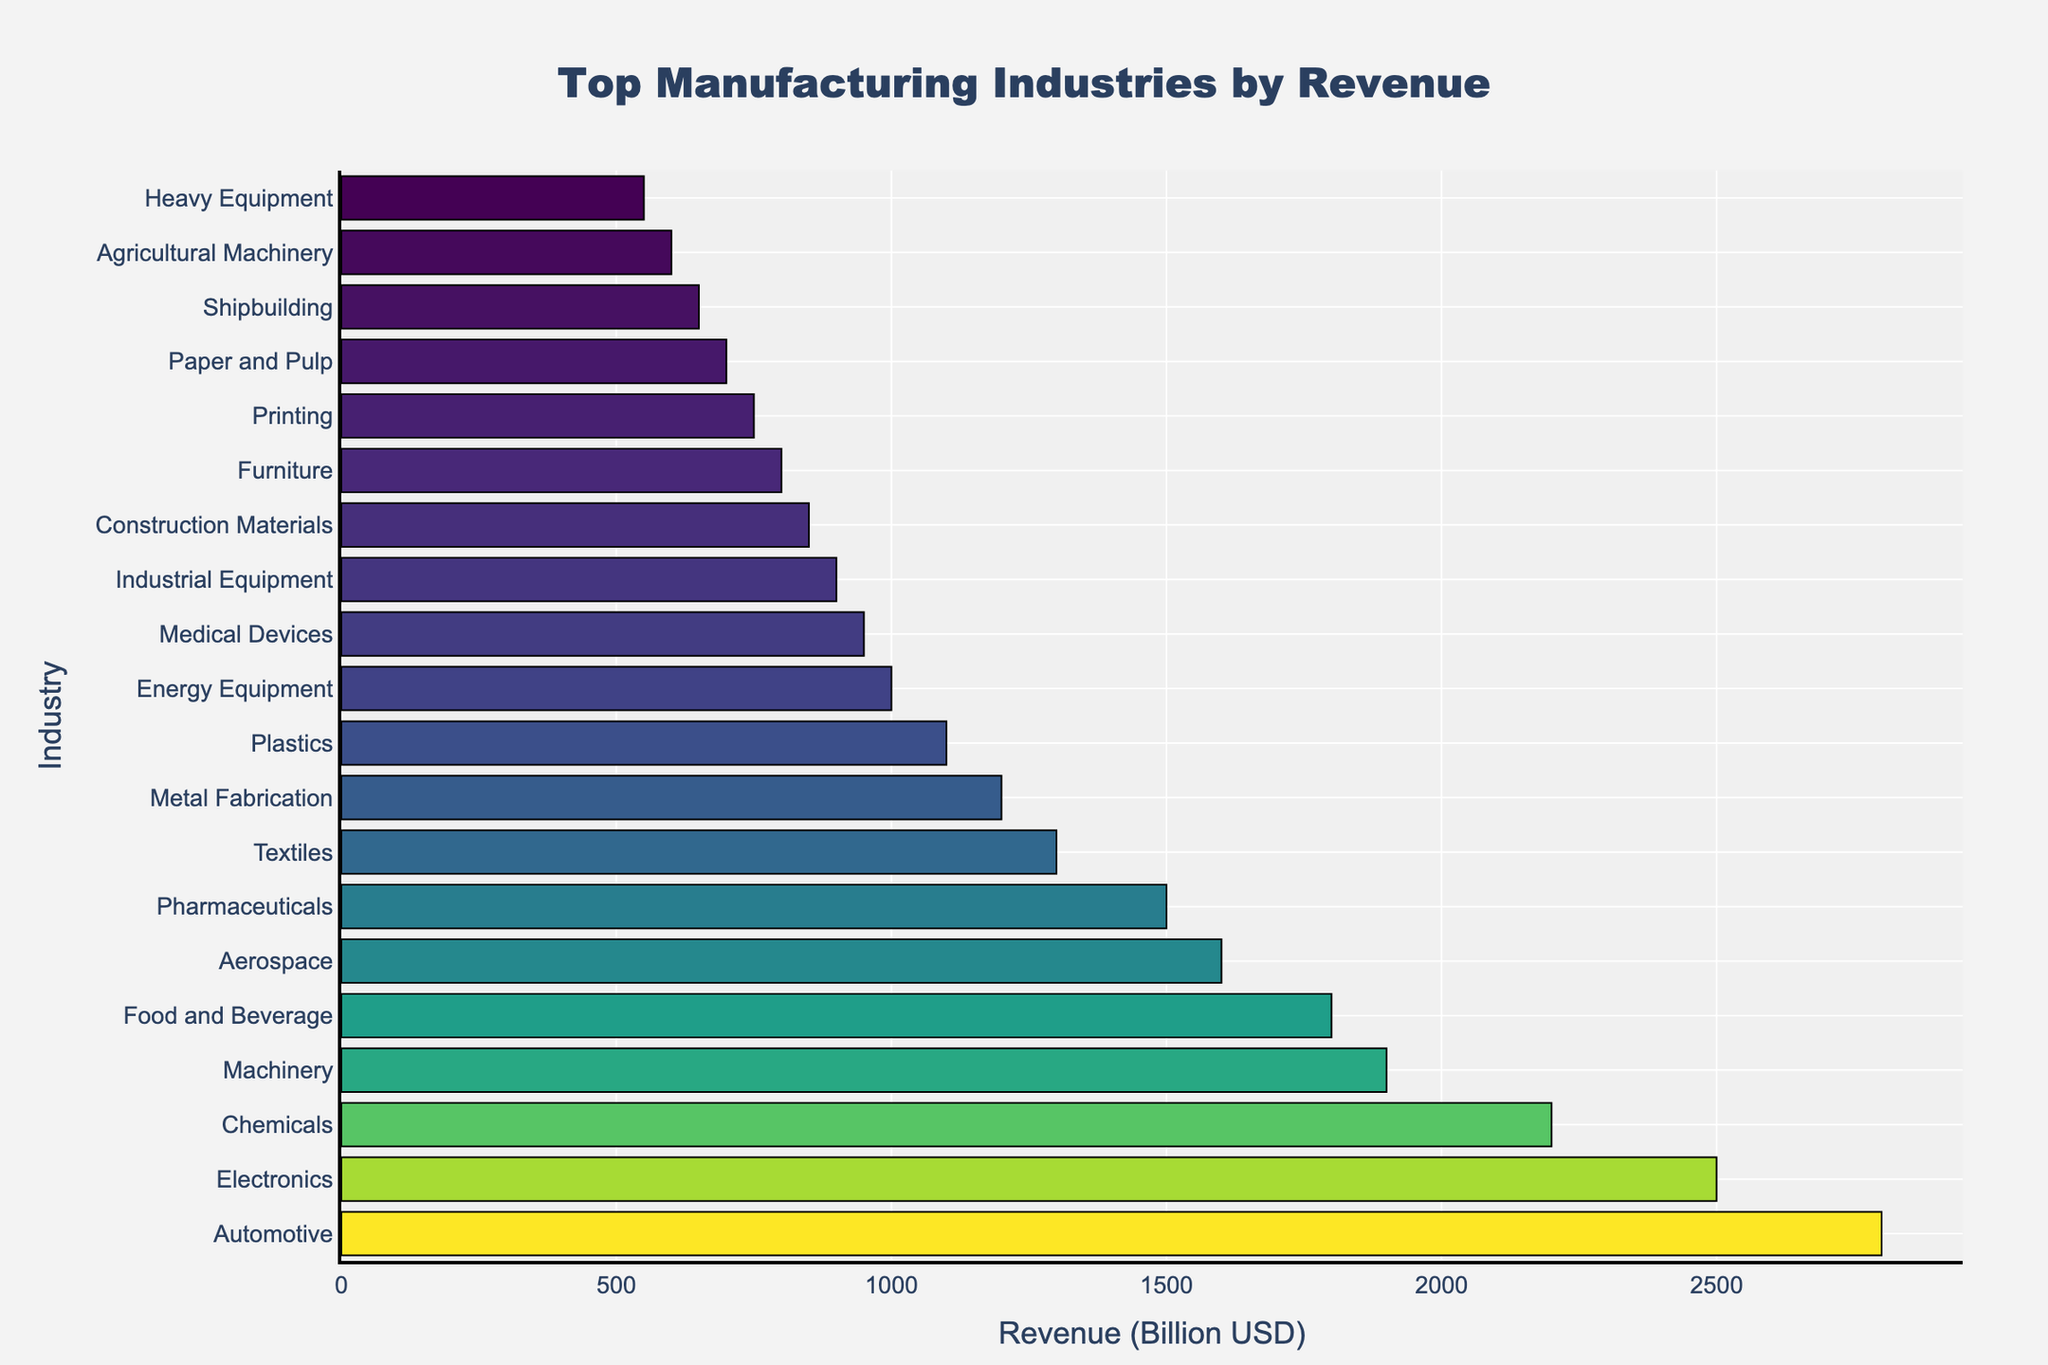Which industry has the highest revenue? Look at the bar chart and identify the longest bar. The Automotive industry has the longest bar, indicating the highest revenue.
Answer: Automotive Which industry has the lowest revenue? Check the bar chart for the shortest bar. The Heavy Equipment industry has the shortest bar, indicating the lowest revenue.
Answer: Heavy Equipment How much more revenue does the Automotive industry generate compared to the Aerospace industry? Locate the bars for Automotive and Aerospace. The Automotive industry's revenue is 2800 billion USD, and the Aerospace industry's revenue is 1600 billion USD. Subtract the Aerospace revenue from the Automotive revenue (2800 - 1600).
Answer: 1200 billion USD What is the combined revenue of the top three industries? Find the values for the top three industries: Automotive (2800), Electronics (2500), and Chemicals (2200). Add these values together (2800 + 2500 + 2200).
Answer: 7500 billion USD How does the revenue of the Textiles industry compare to that of the Pharmaceuticals industry? Compare the positions of the Textiles and Pharmaceuticals bars. The Pharmaceuticals industry has a revenue of 1500 billion USD, and the Textiles industry has a revenue of 1300 billion USD. The Pharmaceuticals industry has a higher revenue.
Answer: Pharmaceuticals industry has higher revenue Which industries have revenues between 1000 billion USD and 1500 billion USD? Examine the lengths of the bars between these values. The industries are Pharmaceuticals (1500), Textiles (1300), Metal Fabrication (1200), and Plastics (1100).
Answer: Pharmaceuticals, Textiles, Metal Fabrication, Plastics What is the average revenue of the bottom five industries? Identify the bottom five industries: Shipbuilding (650), Agricultural Machinery (600), Heavy Equipment (550), Paper and Pulp (700), and Printing (750). Sum these revenues (650 + 600 + 550 + 700 + 750) and divide by 5. (3250/5).
Answer: 650 billion USD How much more revenue does the Pharmaceuticals industry generate compared to the Food and Beverage industry? Locate the bars for Pharmaceuticals and Food and Beverage. Pharmaceuticals revenue is 1500 billion USD, and Food and Beverage is 1800 billion USD. Subtract the Food and Beverage revenue from Pharmaceuticals revenue. (1800 - 1500).
Answer: 300 billion USD What is the median revenue of all the industries listed? List the revenues in ascending order and find the middle value. Revenues: [550, 600, 650, 700, 750, 800, 850, 900, 950, 1000, 1100, 1200, 1300, 1500, 1600, 1800, 1900, 2200, 2500, 2800]. The middle values are 1000 and 1100, so the median is (1000 + 1100) / 2.
Answer: 1050 billion USD 